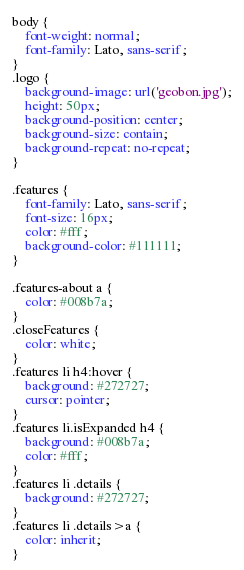Convert code to text. <code><loc_0><loc_0><loc_500><loc_500><_CSS_>body {
    font-weight: normal;
    font-family: Lato, sans-serif;
}
.logo {
    background-image: url('geobon.jpg');
    height: 50px;
    background-position: center;
    background-size: contain;
    background-repeat: no-repeat;
}

.features {
    font-family: Lato, sans-serif;
    font-size: 16px;
    color: #fff;
    background-color: #111111;
}

.features-about a {
    color: #008b7a;
}
.closeFeatures {
    color: white;
}
.features li h4:hover {
    background: #272727;
    cursor: pointer;
}
.features li.isExpanded h4 {
    background: #008b7a;
    color: #fff;
}
.features li .details {
    background: #272727;
}
.features li .details>a {
    color: inherit;
}</code> 